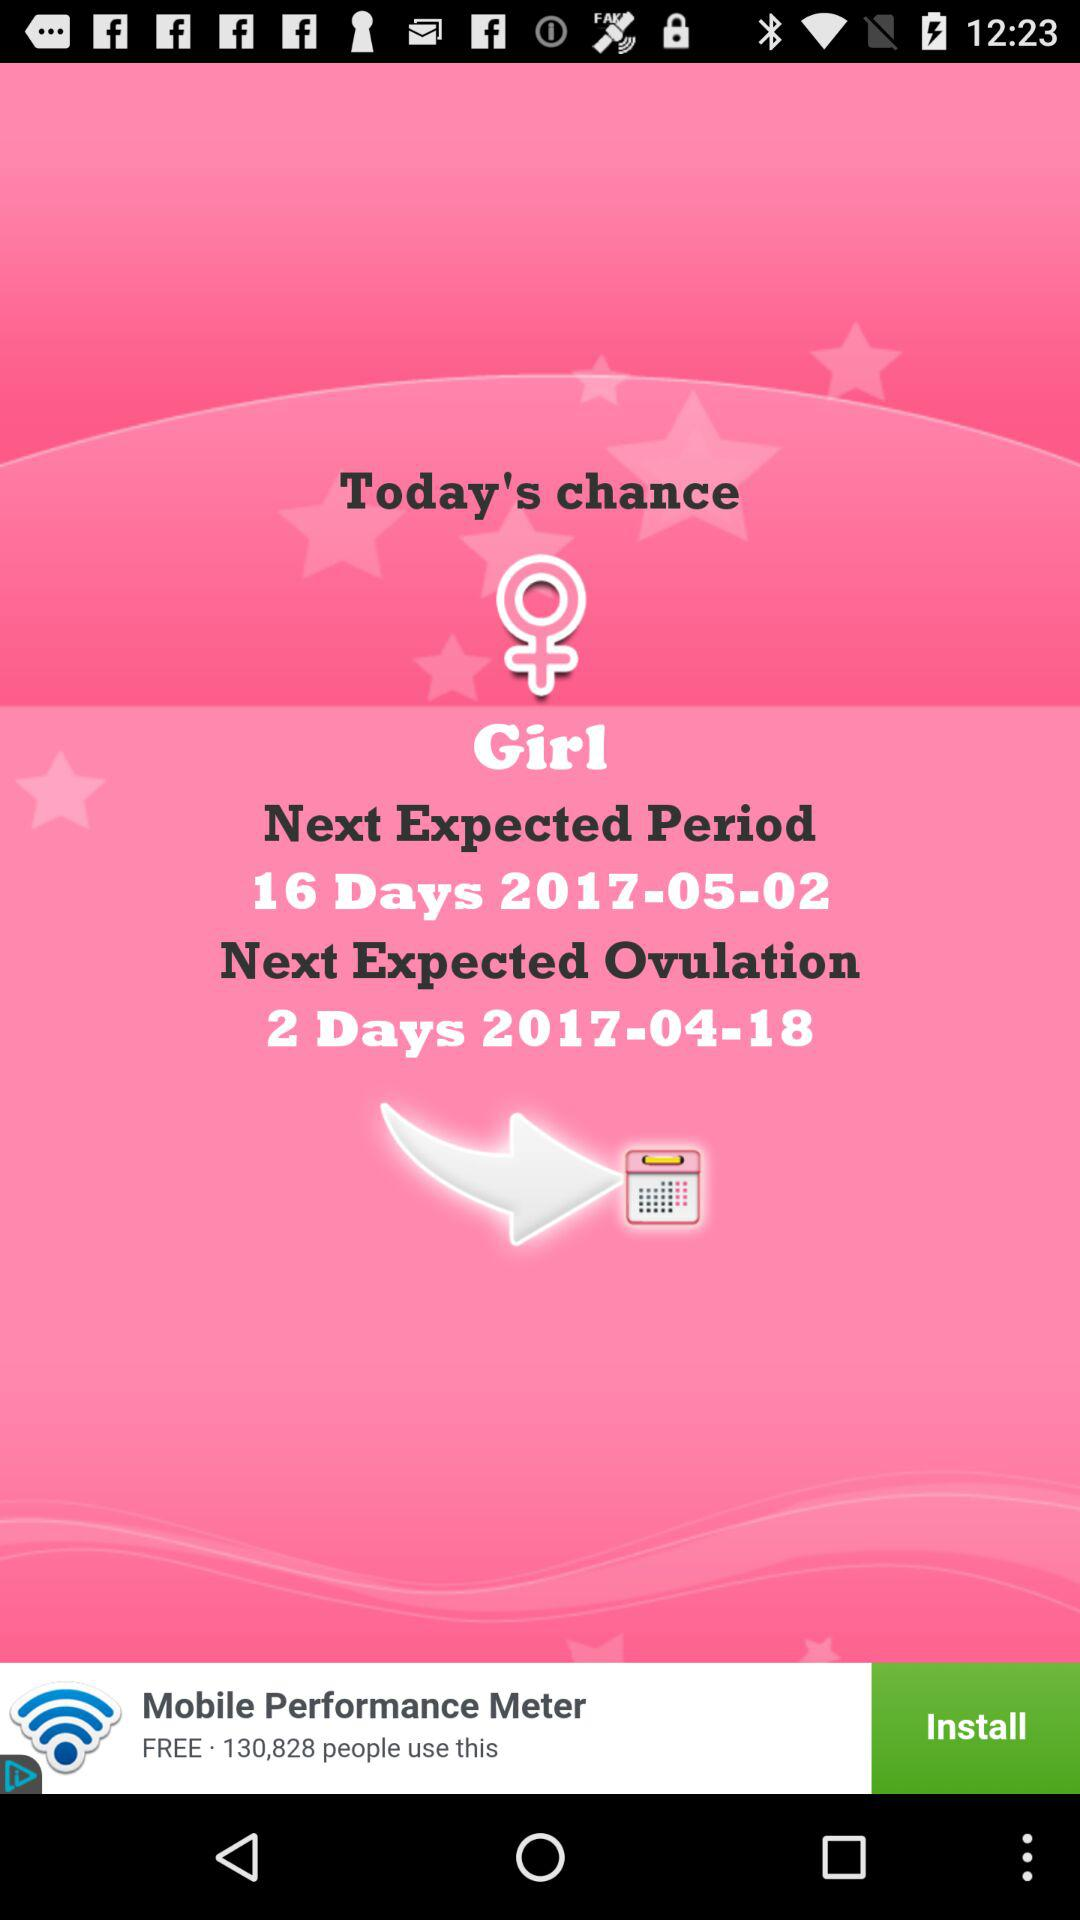What is the gender?
Answer the question using a single word or phrase. It's a girl. 